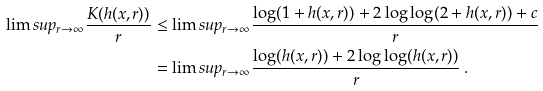<formula> <loc_0><loc_0><loc_500><loc_500>\lim s u p _ { r \to \infty } \frac { K ( h ( x , r ) ) } { r } & \leq \lim s u p _ { r \to \infty } \frac { \log ( 1 + h ( x , r ) ) + 2 \log \log ( 2 + h ( x , r ) ) + c } { r } \\ & = \lim s u p _ { r \to \infty } \frac { \log ( h ( x , r ) ) + 2 \log \log ( h ( x , r ) ) } { r } \, .</formula> 